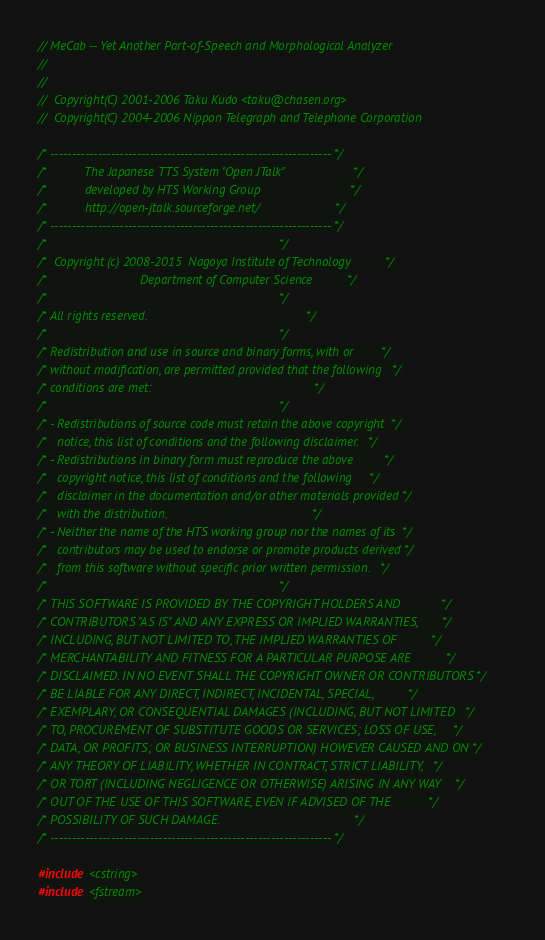Convert code to text. <code><loc_0><loc_0><loc_500><loc_500><_C++_>// MeCab -- Yet Another Part-of-Speech and Morphological Analyzer
//
//
//  Copyright(C) 2001-2006 Taku Kudo <taku@chasen.org>
//  Copyright(C) 2004-2006 Nippon Telegraph and Telephone Corporation

/* ----------------------------------------------------------------- */
/*           The Japanese TTS System "Open JTalk"                    */
/*           developed by HTS Working Group                          */
/*           http://open-jtalk.sourceforge.net/                      */
/* ----------------------------------------------------------------- */
/*                                                                   */
/*  Copyright (c) 2008-2015  Nagoya Institute of Technology          */
/*                           Department of Computer Science          */
/*                                                                   */
/* All rights reserved.                                              */
/*                                                                   */
/* Redistribution and use in source and binary forms, with or        */
/* without modification, are permitted provided that the following   */
/* conditions are met:                                               */
/*                                                                   */
/* - Redistributions of source code must retain the above copyright  */
/*   notice, this list of conditions and the following disclaimer.   */
/* - Redistributions in binary form must reproduce the above         */
/*   copyright notice, this list of conditions and the following     */
/*   disclaimer in the documentation and/or other materials provided */
/*   with the distribution.                                          */
/* - Neither the name of the HTS working group nor the names of its  */
/*   contributors may be used to endorse or promote products derived */
/*   from this software without specific prior written permission.   */
/*                                                                   */
/* THIS SOFTWARE IS PROVIDED BY THE COPYRIGHT HOLDERS AND            */
/* CONTRIBUTORS "AS IS" AND ANY EXPRESS OR IMPLIED WARRANTIES,       */
/* INCLUDING, BUT NOT LIMITED TO, THE IMPLIED WARRANTIES OF          */
/* MERCHANTABILITY AND FITNESS FOR A PARTICULAR PURPOSE ARE          */
/* DISCLAIMED. IN NO EVENT SHALL THE COPYRIGHT OWNER OR CONTRIBUTORS */
/* BE LIABLE FOR ANY DIRECT, INDIRECT, INCIDENTAL, SPECIAL,          */
/* EXEMPLARY, OR CONSEQUENTIAL DAMAGES (INCLUDING, BUT NOT LIMITED   */
/* TO, PROCUREMENT OF SUBSTITUTE GOODS OR SERVICES; LOSS OF USE,     */
/* DATA, OR PROFITS; OR BUSINESS INTERRUPTION) HOWEVER CAUSED AND ON */
/* ANY THEORY OF LIABILITY, WHETHER IN CONTRACT, STRICT LIABILITY,   */
/* OR TORT (INCLUDING NEGLIGENCE OR OTHERWISE) ARISING IN ANY WAY    */
/* OUT OF THE USE OF THIS SOFTWARE, EVEN IF ADVISED OF THE           */
/* POSSIBILITY OF SUCH DAMAGE.                                       */
/* ----------------------------------------------------------------- */

#include <cstring>
#include <fstream></code> 